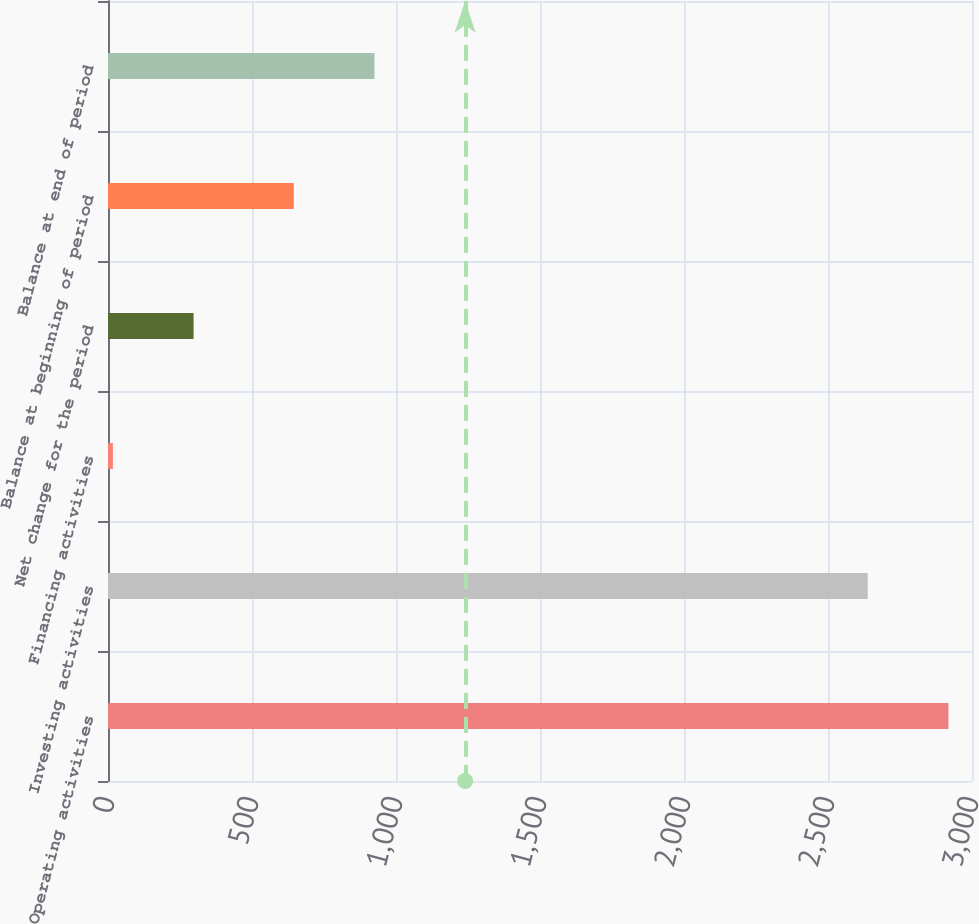<chart> <loc_0><loc_0><loc_500><loc_500><bar_chart><fcel>Operating activities<fcel>Investing activities<fcel>Financing activities<fcel>Net change for the period<fcel>Balance at beginning of period<fcel>Balance at end of period<nl><fcel>2918.2<fcel>2638<fcel>17<fcel>297.2<fcel>645<fcel>925.2<nl></chart> 